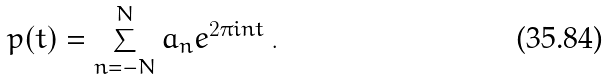Convert formula to latex. <formula><loc_0><loc_0><loc_500><loc_500>p ( t ) = \sum _ { n = - N } ^ { N } a _ { n } e ^ { 2 \pi i n t } \, .</formula> 